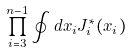Convert formula to latex. <formula><loc_0><loc_0><loc_500><loc_500>\prod _ { i = 3 } ^ { n - 1 } \oint d x _ { i } J _ { i } ^ { * } ( x _ { i } )</formula> 